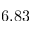Convert formula to latex. <formula><loc_0><loc_0><loc_500><loc_500>6 . 8 3</formula> 